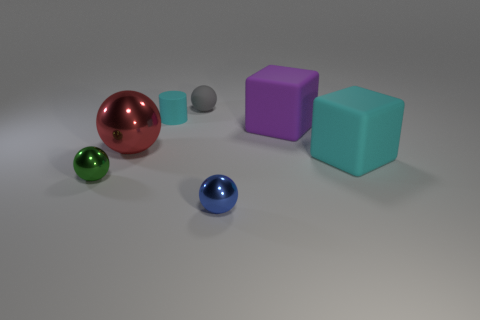Is there anything else of the same color as the rubber cylinder?
Ensure brevity in your answer.  Yes. There is a big cyan object; are there any cyan matte things behind it?
Your answer should be compact. Yes. Is there a gray object that has the same size as the rubber ball?
Ensure brevity in your answer.  No. There is another small ball that is made of the same material as the tiny blue sphere; what color is it?
Your answer should be compact. Green. What is the cylinder made of?
Ensure brevity in your answer.  Rubber. What is the shape of the large red shiny thing?
Offer a very short reply. Sphere. How many matte things are the same color as the cylinder?
Ensure brevity in your answer.  1. What is the material of the cylinder that is right of the shiny object behind the tiny shiny object to the left of the red metal sphere?
Make the answer very short. Rubber. How many cyan things are either blocks or tiny metal objects?
Ensure brevity in your answer.  1. How big is the cyan thing in front of the large metal sphere behind the small metallic object right of the tiny gray rubber sphere?
Provide a succinct answer. Large. 